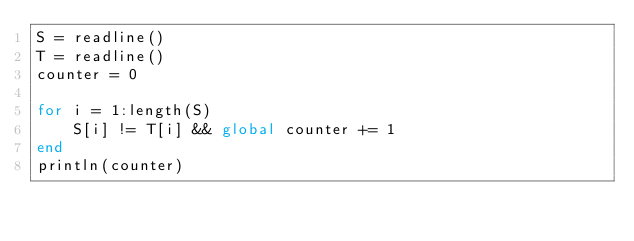<code> <loc_0><loc_0><loc_500><loc_500><_Julia_>S = readline()
T = readline()
counter = 0

for i = 1:length(S)
	S[i] != T[i] && global counter += 1
end
println(counter)</code> 